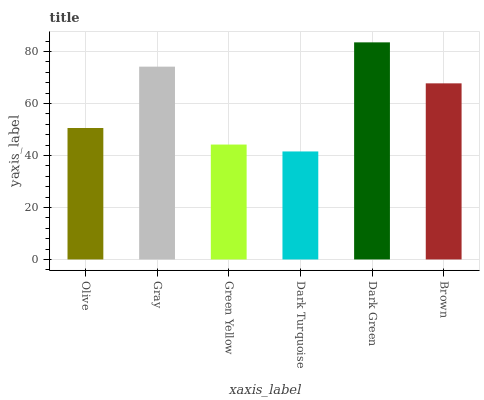Is Dark Turquoise the minimum?
Answer yes or no. Yes. Is Dark Green the maximum?
Answer yes or no. Yes. Is Gray the minimum?
Answer yes or no. No. Is Gray the maximum?
Answer yes or no. No. Is Gray greater than Olive?
Answer yes or no. Yes. Is Olive less than Gray?
Answer yes or no. Yes. Is Olive greater than Gray?
Answer yes or no. No. Is Gray less than Olive?
Answer yes or no. No. Is Brown the high median?
Answer yes or no. Yes. Is Olive the low median?
Answer yes or no. Yes. Is Gray the high median?
Answer yes or no. No. Is Green Yellow the low median?
Answer yes or no. No. 